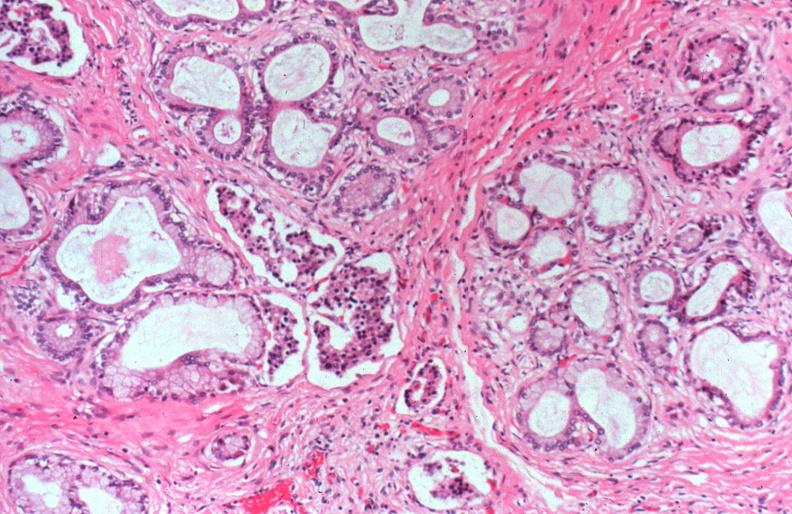where is this?
Answer the question using a single word or phrase. Pancreas 